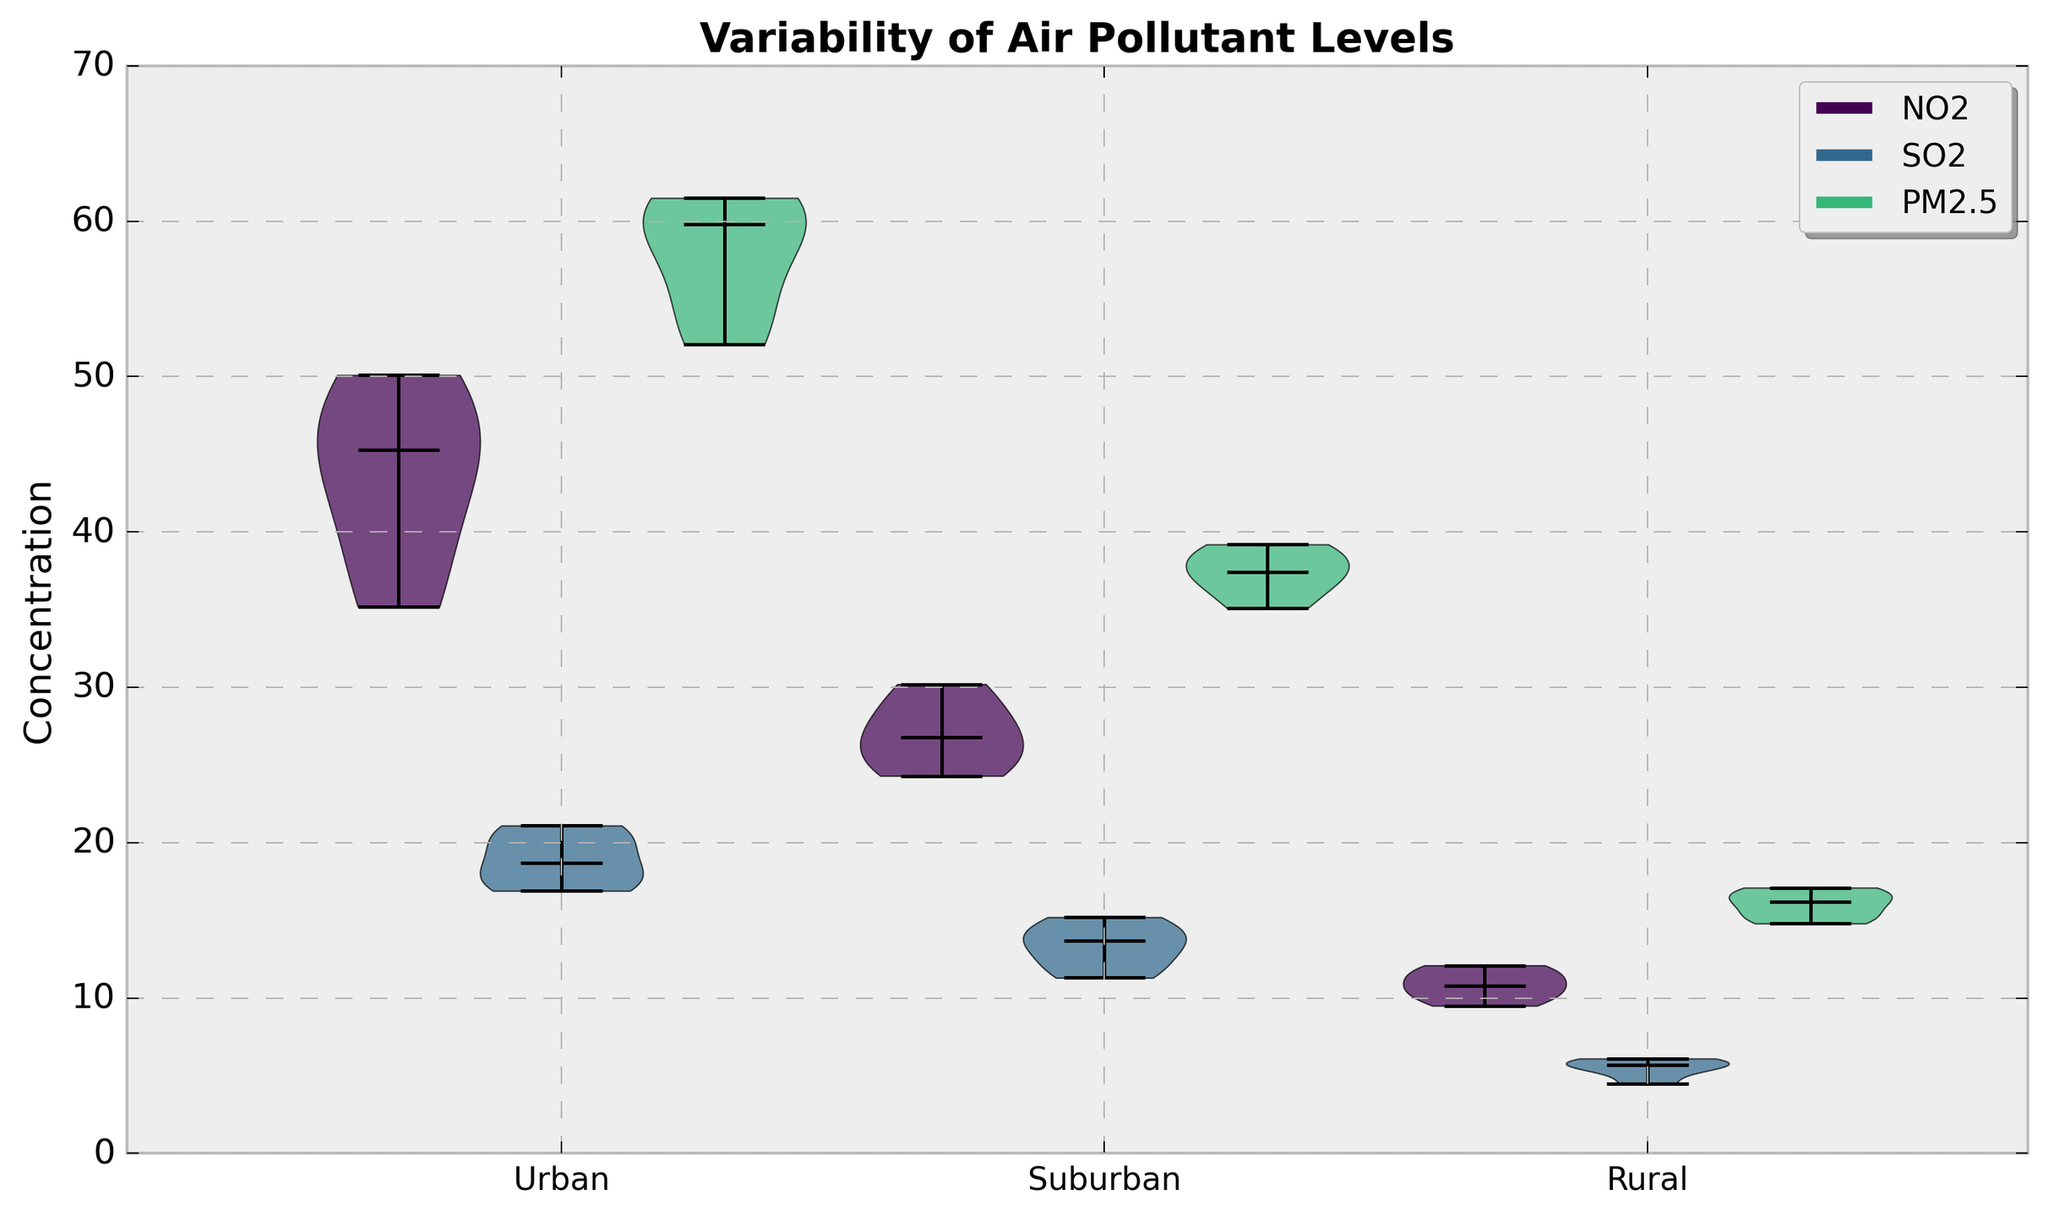What area has the highest concentration of NO2? The area with the highest concentration can be deduced by comparing the NO2 violins. Looking at the plot, Urban areas have the highest median NO2 levels.
Answer: Urban Which pollutant shows the most variability in the Urban area? To identify the variability, examine the width and spread of violins. The PM2.5 violin for Urban areas is visibly wider and spread out, suggesting the greatest variability.
Answer: PM2.5 Between PM2.5 levels in Urban and Rural areas, which shows less variability? By comparing the width and spread of the violins, Rural areas show a narrower and more compact PM2.5 distribution, indicating less variability compared to Urban areas.
Answer: Rural Is the median concentration of SO2 higher in Urban or Suburban areas? Compare the median lines (horizontal bar within the violin plots). The Urban area has a higher median line for SO2 compared to Suburban.
Answer: Urban Overall, which area has the lowest levels of NO2, SO2, and PM2.5? Looking at the lower ends of the violins for all three pollutants, Rural areas consistently have the lowest concentrations across NO2, SO2, and PM2.5.
Answer: Rural Which pollutant in Suburban areas has the widest distribution? Assess the width of the violins. PM2.5 in the Suburban area has a wider and more spread violin compared to NO2 and SO2, indicating the widest distribution.
Answer: PM2.5 Is the median concentration of PM2.5 higher in Urban or Suburban areas? The position of the horizontal median bar within the violins shows the Urban area's median concentration of PM2.5 is higher than the Suburban.
Answer: Urban How does the spread of SO2 levels in Rural areas compare to the spread in Urban areas? By comparing the width and length of the violins for SO2 between Rural and Urban areas, Rural SO2 levels show a much narrower and less spread-out distribution than Urban levels.
Answer: Rural spread is narrower Does the PM2.5 in Suburban areas exhibit more variability than SO2 in the same area? Comparing the width and spread of violins for PM2.5 and SO2 in Suburban areas, the PM2.5 violin is wider, indicating higher variability.
Answer: Yes Which pollutant shows the smallest spread in all areas? Compare the violins for all areas and pollutants to determine which one is most compact. SO2, especially in Rural and Urban areas, often appears the most compact across the three pollutants.
Answer: SO2 